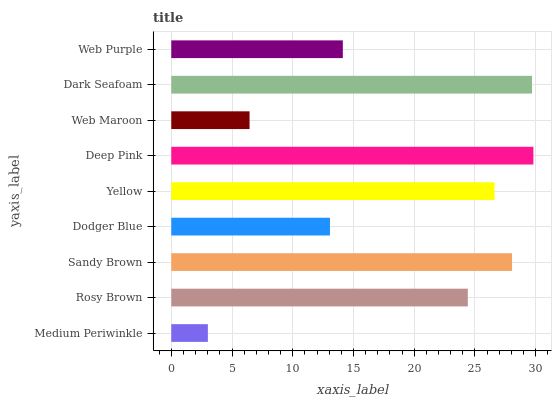Is Medium Periwinkle the minimum?
Answer yes or no. Yes. Is Deep Pink the maximum?
Answer yes or no. Yes. Is Rosy Brown the minimum?
Answer yes or no. No. Is Rosy Brown the maximum?
Answer yes or no. No. Is Rosy Brown greater than Medium Periwinkle?
Answer yes or no. Yes. Is Medium Periwinkle less than Rosy Brown?
Answer yes or no. Yes. Is Medium Periwinkle greater than Rosy Brown?
Answer yes or no. No. Is Rosy Brown less than Medium Periwinkle?
Answer yes or no. No. Is Rosy Brown the high median?
Answer yes or no. Yes. Is Rosy Brown the low median?
Answer yes or no. Yes. Is Web Purple the high median?
Answer yes or no. No. Is Deep Pink the low median?
Answer yes or no. No. 